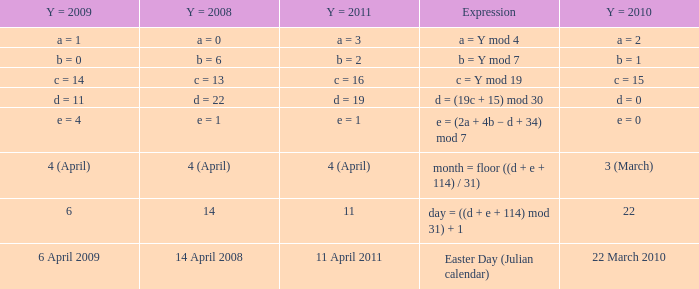What is the y = 2011 when the expression is month = floor ((d + e + 114) / 31)? 4 (April). 